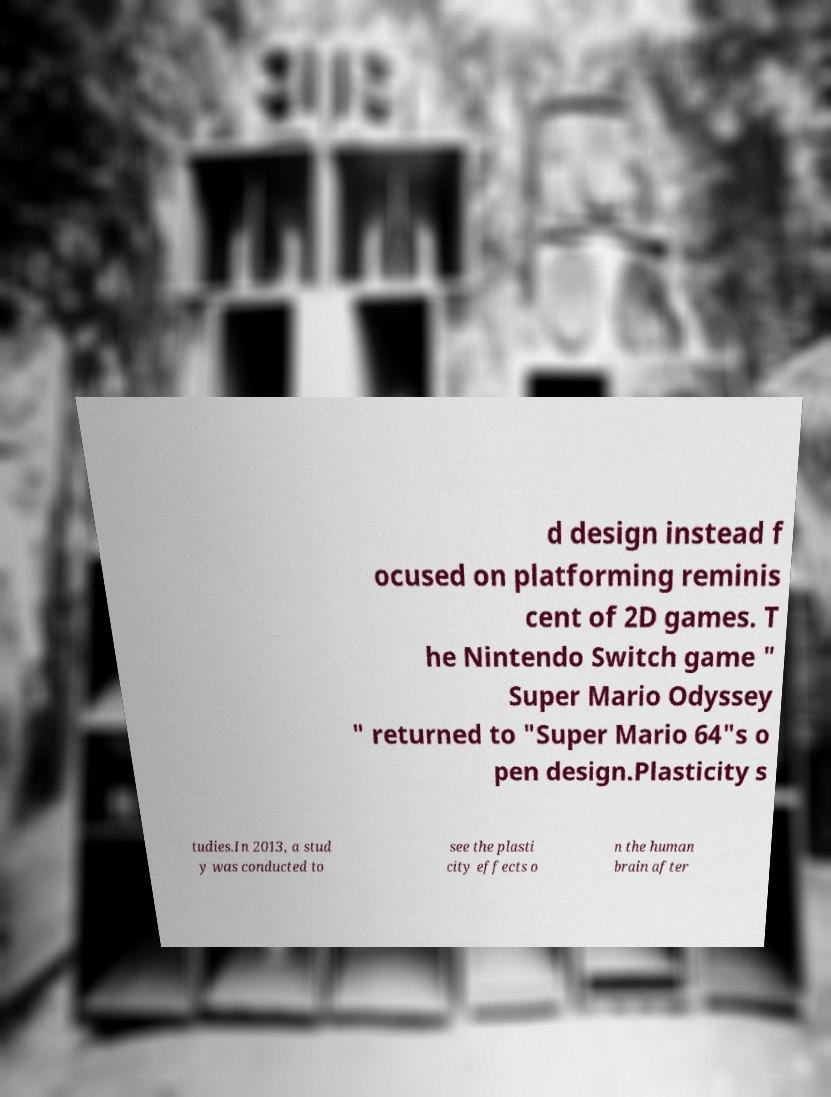Could you assist in decoding the text presented in this image and type it out clearly? d design instead f ocused on platforming reminis cent of 2D games. T he Nintendo Switch game " Super Mario Odyssey " returned to "Super Mario 64"s o pen design.Plasticity s tudies.In 2013, a stud y was conducted to see the plasti city effects o n the human brain after 